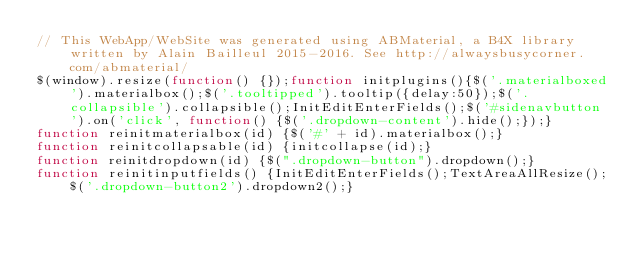Convert code to text. <code><loc_0><loc_0><loc_500><loc_500><_JavaScript_>// This WebApp/WebSite was generated using ABMaterial, a B4X library written by Alain Bailleul 2015-2016. See http://alwaysbusycorner.com/abmaterial/
$(window).resize(function() {});function initplugins(){$('.materialboxed').materialbox();$('.tooltipped').tooltip({delay:50});$('.collapsible').collapsible();InitEditEnterFields();$('#sidenavbutton').on('click', function() {$('.dropdown-content').hide();});}
function reinitmaterialbox(id) {$('#' + id).materialbox();}
function reinitcollapsable(id) {initcollapse(id);}
function reinitdropdown(id) {$(".dropdown-button").dropdown();}
function reinitinputfields() {InitEditEnterFields();TextAreaAllResize();$('.dropdown-button2').dropdown2();}</code> 